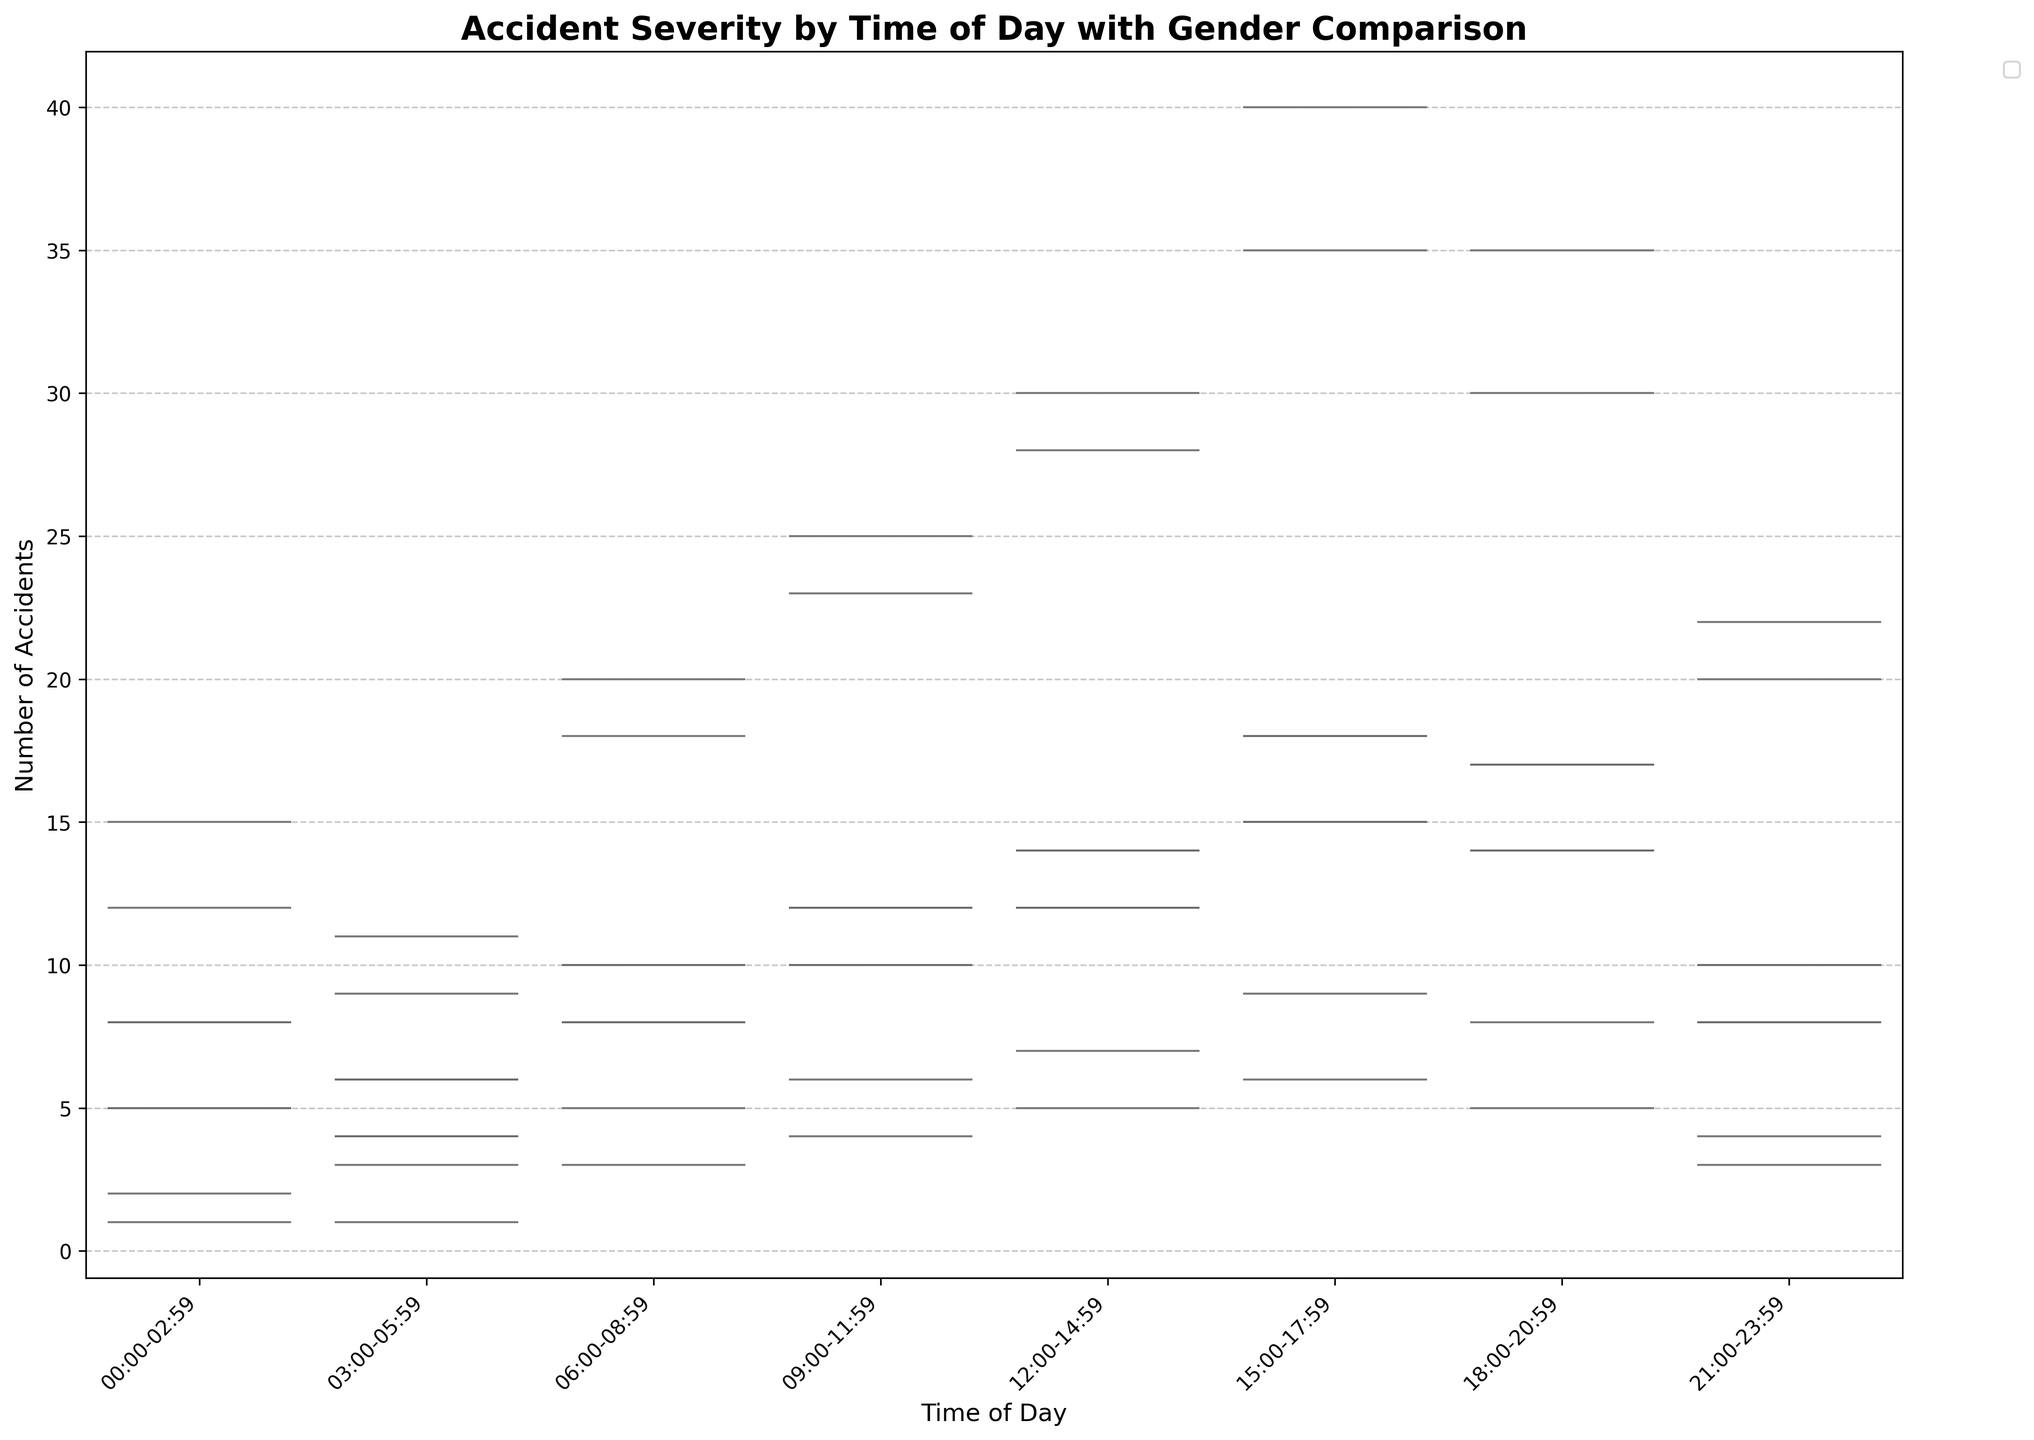What is the title of the plot? The title of the plot is displayed prominently at the top of the figure. It provides an overview of what the data visualization represents.
Answer: Accident Severity by Time of Day with Gender Comparison What does the x-axis represent? The x-axis at the bottom of the plot shows "Time of Day," indicating different time intervals during a 24-hour period.
Answer: Time of Day What colors are used to represent different accident severity levels? There are three different colors used in the plot to represent various accident severity levels. Minor Injury is typically in light red, Serious Injury in light blue, and Fatal in light green.
Answer: Light red, light blue, and light green During which time period do males have the highest number of minor injuries? By observing the height and width of the violins, it is clear that the largest male minor injury count occurs during 15:00-17:59.
Answer: 15:00-17:59 Which gender has a higher count of serious injuries from 18:00-20:59? Comparing the split violins for the time interval 18:00-20:59, the male side is wider and taller, indicating a higher count of serious injuries for males during this time.
Answer: Male How does the number of female fatal accidents compare between 00:00-02:59 and 21:00-23:59? The width and height of the violins for female fatal accidents show that the numbers are slightly higher for 21:00-23:59 than 00:00-02:59.
Answer: 21:00-23:59 > 00:00-02:59 What is the total count of male accidents in the 09:00-11:59 period across all severity levels? Add the counts for male accidents in this time period: Minor Injury (25) + Serious Injury (12) + Fatal (6).
Answer: 43 Which period shows the lowest count of accidents for both genders combined? By comparing the total heights for male and female counts in each period, the 03:00-05:59 period has the lowest combined height, indicating the lowest count of accidents.
Answer: 03:00-05:59 What is the difference in the number of female minor injuries between 15:00-17:59 and 18:00-20:59? Subtract the count for 18:00-20:59 from that of 15:00-17:59: 35 (15:00-17:59) - 30 (18:00-20:59).
Answer: 5 During which time period do females have a higher number of serious injuries than males? By comparing violins across all time periods, note that from 12:00-14:59, females do not surpass males. Other periods need consideration, but no distinct higher count is evident from the visual information.
Answer: None 